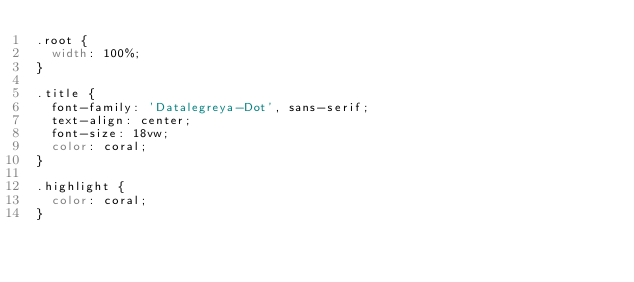Convert code to text. <code><loc_0><loc_0><loc_500><loc_500><_CSS_>.root {
  width: 100%;
}

.title {
  font-family: 'Datalegreya-Dot', sans-serif;
  text-align: center;
  font-size: 18vw;
  color: coral;
}

.highlight {
  color: coral;
}
</code> 